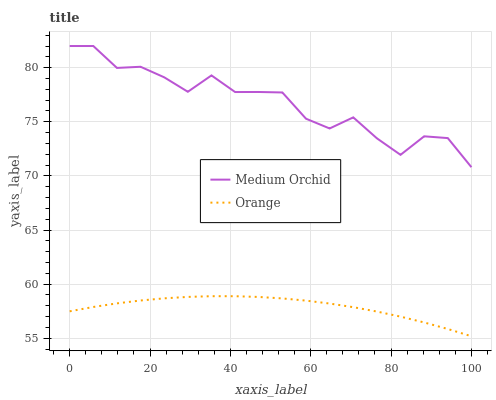Does Orange have the minimum area under the curve?
Answer yes or no. Yes. Does Medium Orchid have the maximum area under the curve?
Answer yes or no. Yes. Does Medium Orchid have the minimum area under the curve?
Answer yes or no. No. Is Orange the smoothest?
Answer yes or no. Yes. Is Medium Orchid the roughest?
Answer yes or no. Yes. Is Medium Orchid the smoothest?
Answer yes or no. No. Does Medium Orchid have the lowest value?
Answer yes or no. No. Does Medium Orchid have the highest value?
Answer yes or no. Yes. Is Orange less than Medium Orchid?
Answer yes or no. Yes. Is Medium Orchid greater than Orange?
Answer yes or no. Yes. Does Orange intersect Medium Orchid?
Answer yes or no. No. 